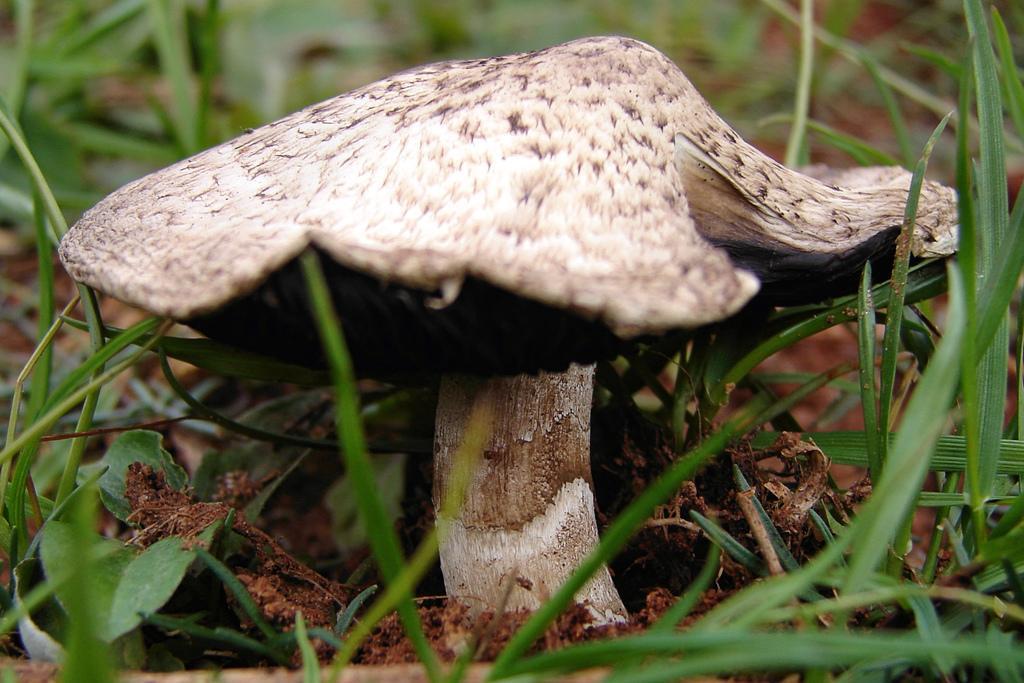Please provide a concise description of this image. In this image we can see a mushroom on the ground. 